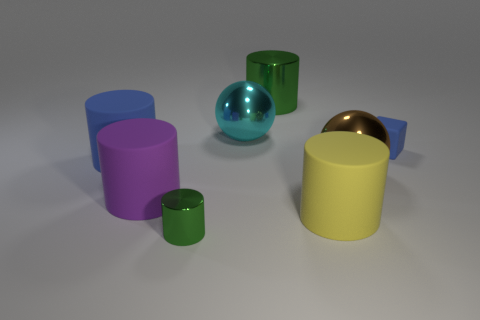Are there fewer tiny green cylinders behind the cyan object than purple cylinders?
Keep it short and to the point. Yes. There is a yellow thing that is made of the same material as the blue cylinder; what shape is it?
Ensure brevity in your answer.  Cylinder. How many tiny cylinders have the same color as the cube?
Ensure brevity in your answer.  0. How many objects are big blue cylinders or big metallic balls?
Ensure brevity in your answer.  3. The cylinder that is behind the cyan shiny thing on the right side of the tiny metal cylinder is made of what material?
Give a very brief answer. Metal. Is there a large green sphere that has the same material as the large blue object?
Offer a very short reply. No. What is the shape of the blue rubber thing to the left of the large matte thing on the right side of the shiny object in front of the brown metallic sphere?
Your answer should be very brief. Cylinder. What material is the big purple cylinder?
Offer a terse response. Rubber. The other sphere that is made of the same material as the brown sphere is what color?
Offer a terse response. Cyan. Is there a big green thing to the left of the metal thing that is in front of the purple cylinder?
Ensure brevity in your answer.  No. 